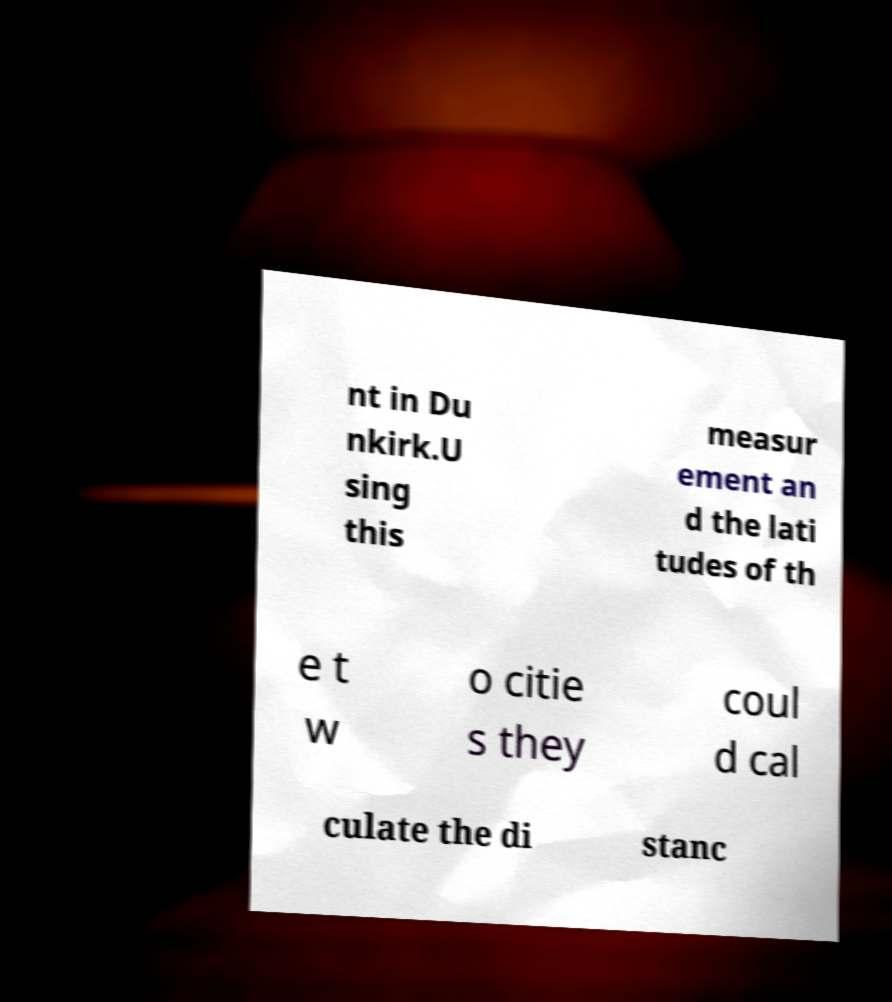Can you read and provide the text displayed in the image?This photo seems to have some interesting text. Can you extract and type it out for me? nt in Du nkirk.U sing this measur ement an d the lati tudes of th e t w o citie s they coul d cal culate the di stanc 